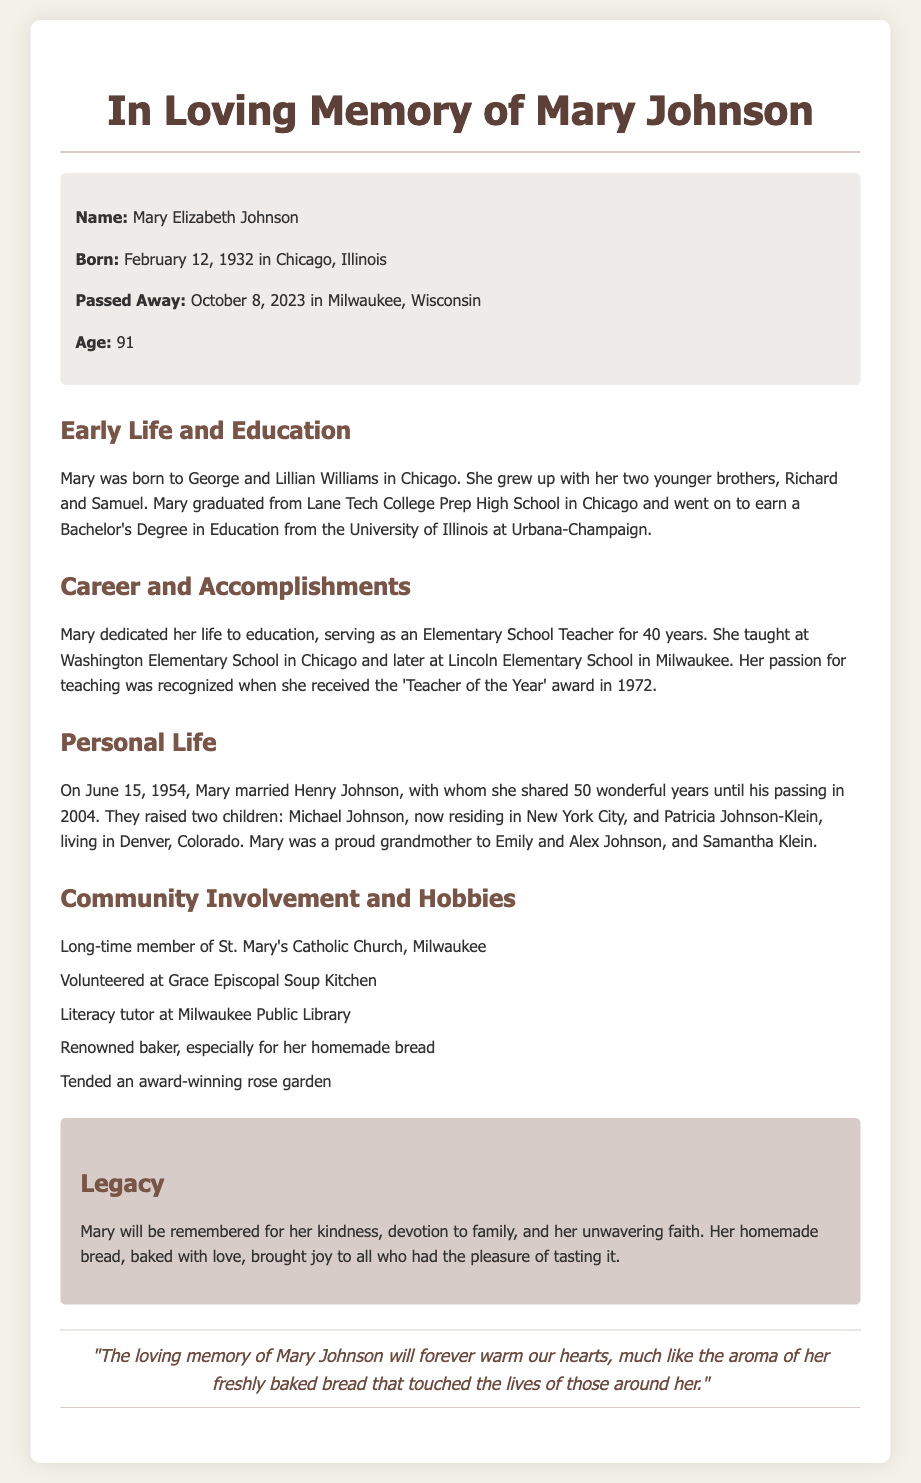What was Mary's full name? The document states her full name is Mary Elizabeth Johnson.
Answer: Mary Elizabeth Johnson When was Mary born? Mary was born on February 12, 1932.
Answer: February 12, 1932 How many years did Mary teach? The document mentions she dedicated 40 years to teaching.
Answer: 40 years What award did Mary receive in 1972? The document notes that she received the 'Teacher of the Year' award in that year.
Answer: Teacher of the Year Who did Mary marry? Mary married Henry Johnson on June 15, 1954.
Answer: Henry Johnson What hobby was Mary renowned for? The document describes her as a renowned baker, especially for her homemade bread.
Answer: Homemade bread How many grandchildren did Mary have? The document indicates she was a proud grandmother to three grandchildren.
Answer: Three What church was Mary a long-time member of? The document states she was a long-time member of St. Mary's Catholic Church.
Answer: St. Mary's Catholic Church What legacy will Mary be remembered for? According to the document, she will be remembered for her kindness and devotion to family.
Answer: Kindness and devotion to family 